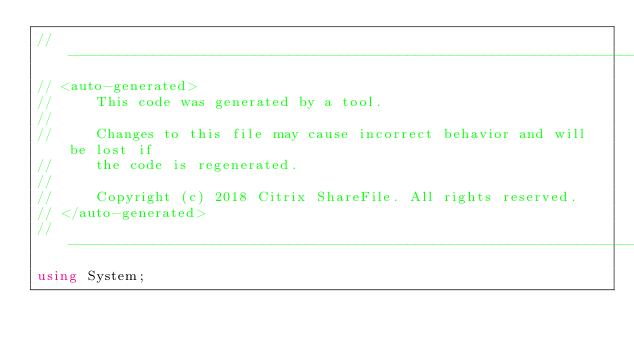<code> <loc_0><loc_0><loc_500><loc_500><_C#_>// ------------------------------------------------------------------------------
// <auto-generated>
//     This code was generated by a tool.
//  
//     Changes to this file may cause incorrect behavior and will be lost if
//     the code is regenerated.
//     
//	   Copyright (c) 2018 Citrix ShareFile. All rights reserved.
// </auto-generated>
// ------------------------------------------------------------------------------
using System;</code> 